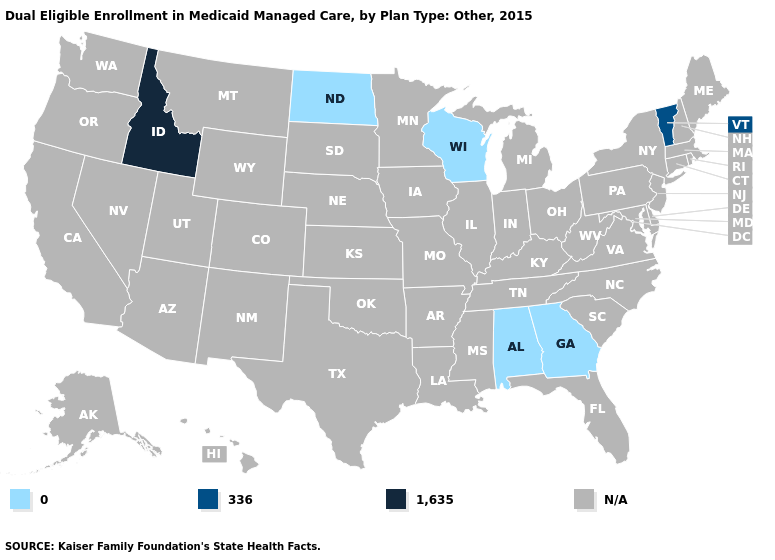Does the first symbol in the legend represent the smallest category?
Quick response, please. Yes. What is the value of New York?
Give a very brief answer. N/A. What is the value of Kentucky?
Be succinct. N/A. Does Vermont have the lowest value in the USA?
Be succinct. No. What is the lowest value in the USA?
Answer briefly. 0. Name the states that have a value in the range N/A?
Short answer required. Alaska, Arizona, Arkansas, California, Colorado, Connecticut, Delaware, Florida, Hawaii, Illinois, Indiana, Iowa, Kansas, Kentucky, Louisiana, Maine, Maryland, Massachusetts, Michigan, Minnesota, Mississippi, Missouri, Montana, Nebraska, Nevada, New Hampshire, New Jersey, New Mexico, New York, North Carolina, Ohio, Oklahoma, Oregon, Pennsylvania, Rhode Island, South Carolina, South Dakota, Tennessee, Texas, Utah, Virginia, Washington, West Virginia, Wyoming. Name the states that have a value in the range 0?
Write a very short answer. Alabama, Georgia, North Dakota, Wisconsin. Name the states that have a value in the range 336?
Quick response, please. Vermont. What is the lowest value in states that border South Dakota?
Give a very brief answer. 0. What is the value of Kansas?
Quick response, please. N/A. How many symbols are there in the legend?
Concise answer only. 4. 